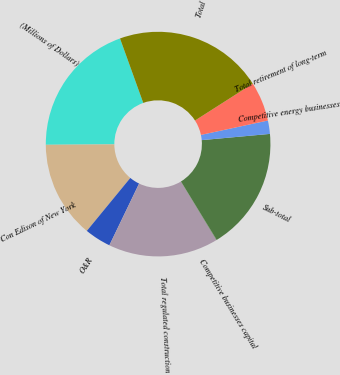<chart> <loc_0><loc_0><loc_500><loc_500><pie_chart><fcel>(Millions of Dollars)<fcel>Con Edison of New York<fcel>O&R<fcel>Total regulated construction<fcel>Competitive businesses capital<fcel>Sub-total<fcel>Competitive energy businesses<fcel>Total retirement of long-term<fcel>Total<nl><fcel>19.59%<fcel>13.96%<fcel>3.8%<fcel>15.83%<fcel>0.05%<fcel>17.71%<fcel>1.92%<fcel>5.68%<fcel>21.46%<nl></chart> 